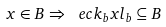<formula> <loc_0><loc_0><loc_500><loc_500>x \in B \Rightarrow \ e c { k _ { b } } { x } { l _ { b } } \subseteq B</formula> 